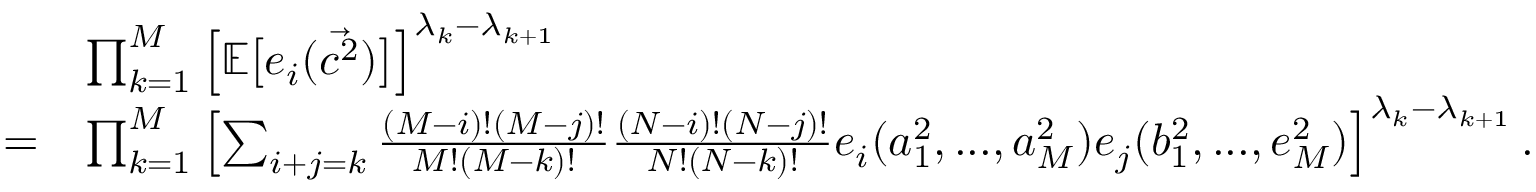<formula> <loc_0><loc_0><loc_500><loc_500>\begin{array} { r l } & { \prod _ { k = 1 } ^ { M } \left [ \mathbb { E } \left [ e _ { i } ( \ V e c { c ^ { 2 } } ) \right ] \right ] ^ { \lambda _ { k } - \lambda _ { k + 1 } } } \\ { = } & { \prod _ { k = 1 } ^ { M } \left [ \sum _ { i + j = k } \frac { ( M - i ) ! ( M - j ) ! } { M ! ( M - k ) ! } \frac { ( N - i ) ! ( N - j ) ! } { N ! ( N - k ) ! } e _ { i } ( a _ { 1 } ^ { 2 } , \dots , a _ { M } ^ { 2 } ) e _ { j } ( b _ { 1 } ^ { 2 } , \dots , e _ { M } ^ { 2 } ) \right ] ^ { \lambda _ { k } - \lambda _ { k + 1 } } . } \end{array}</formula> 